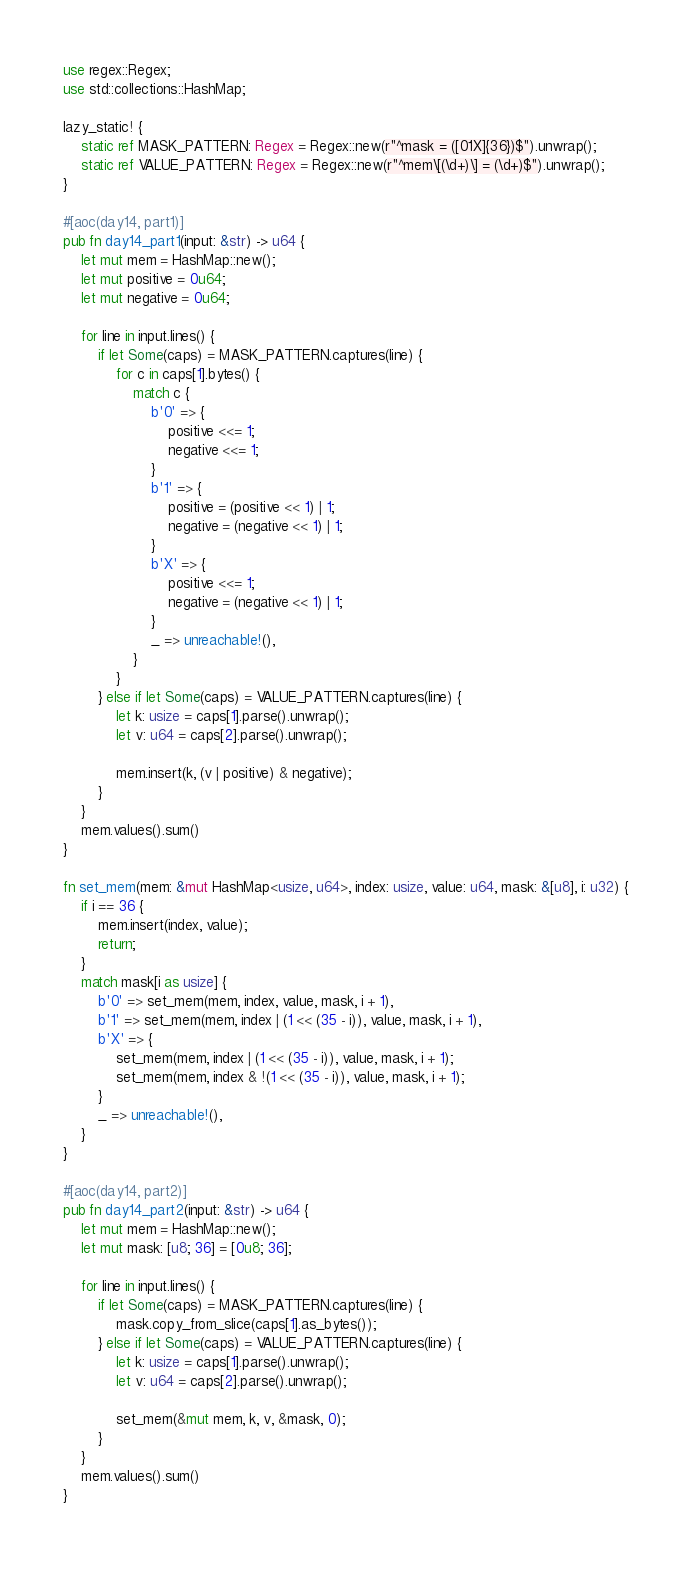Convert code to text. <code><loc_0><loc_0><loc_500><loc_500><_Rust_>use regex::Regex;
use std::collections::HashMap;

lazy_static! {
    static ref MASK_PATTERN: Regex = Regex::new(r"^mask = ([01X]{36})$").unwrap();
    static ref VALUE_PATTERN: Regex = Regex::new(r"^mem\[(\d+)\] = (\d+)$").unwrap();
}

#[aoc(day14, part1)]
pub fn day14_part1(input: &str) -> u64 {
    let mut mem = HashMap::new();
    let mut positive = 0u64;
    let mut negative = 0u64;

    for line in input.lines() {
        if let Some(caps) = MASK_PATTERN.captures(line) {
            for c in caps[1].bytes() {
                match c {
                    b'0' => {
                        positive <<= 1;
                        negative <<= 1;
                    }
                    b'1' => {
                        positive = (positive << 1) | 1;
                        negative = (negative << 1) | 1;
                    }
                    b'X' => {
                        positive <<= 1;
                        negative = (negative << 1) | 1;
                    }
                    _ => unreachable!(),
                }
            }
        } else if let Some(caps) = VALUE_PATTERN.captures(line) {
            let k: usize = caps[1].parse().unwrap();
            let v: u64 = caps[2].parse().unwrap();

            mem.insert(k, (v | positive) & negative);
        }
    }
    mem.values().sum()
}

fn set_mem(mem: &mut HashMap<usize, u64>, index: usize, value: u64, mask: &[u8], i: u32) {
    if i == 36 {
        mem.insert(index, value);
        return;
    }
    match mask[i as usize] {
        b'0' => set_mem(mem, index, value, mask, i + 1),
        b'1' => set_mem(mem, index | (1 << (35 - i)), value, mask, i + 1),
        b'X' => {
            set_mem(mem, index | (1 << (35 - i)), value, mask, i + 1);
            set_mem(mem, index & !(1 << (35 - i)), value, mask, i + 1);
        }
        _ => unreachable!(),
    }
}

#[aoc(day14, part2)]
pub fn day14_part2(input: &str) -> u64 {
    let mut mem = HashMap::new();
    let mut mask: [u8; 36] = [0u8; 36];

    for line in input.lines() {
        if let Some(caps) = MASK_PATTERN.captures(line) {
            mask.copy_from_slice(caps[1].as_bytes());
        } else if let Some(caps) = VALUE_PATTERN.captures(line) {
            let k: usize = caps[1].parse().unwrap();
            let v: u64 = caps[2].parse().unwrap();

            set_mem(&mut mem, k, v, &mask, 0);
        }
    }
    mem.values().sum()
}
</code> 